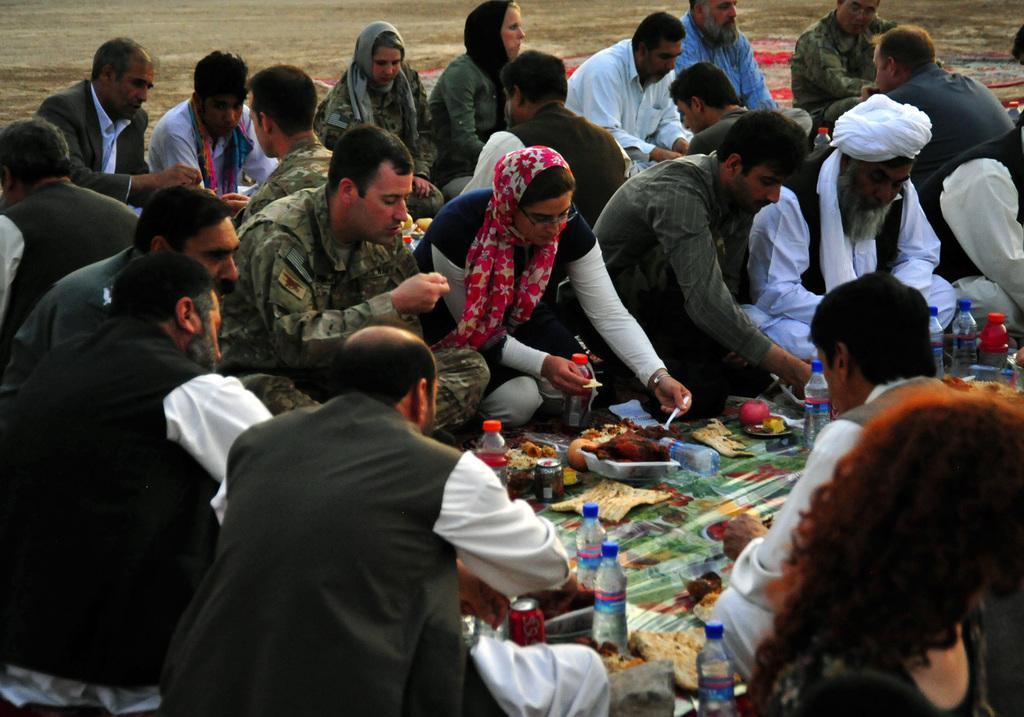How would you summarize this image in a sentence or two? This picture is clicked outside. In the foreground we can see the food items, water bottles and many other items are placed on the ground and we can see the group of people sitting on the ground and eating food. In the background we can see the ground. 